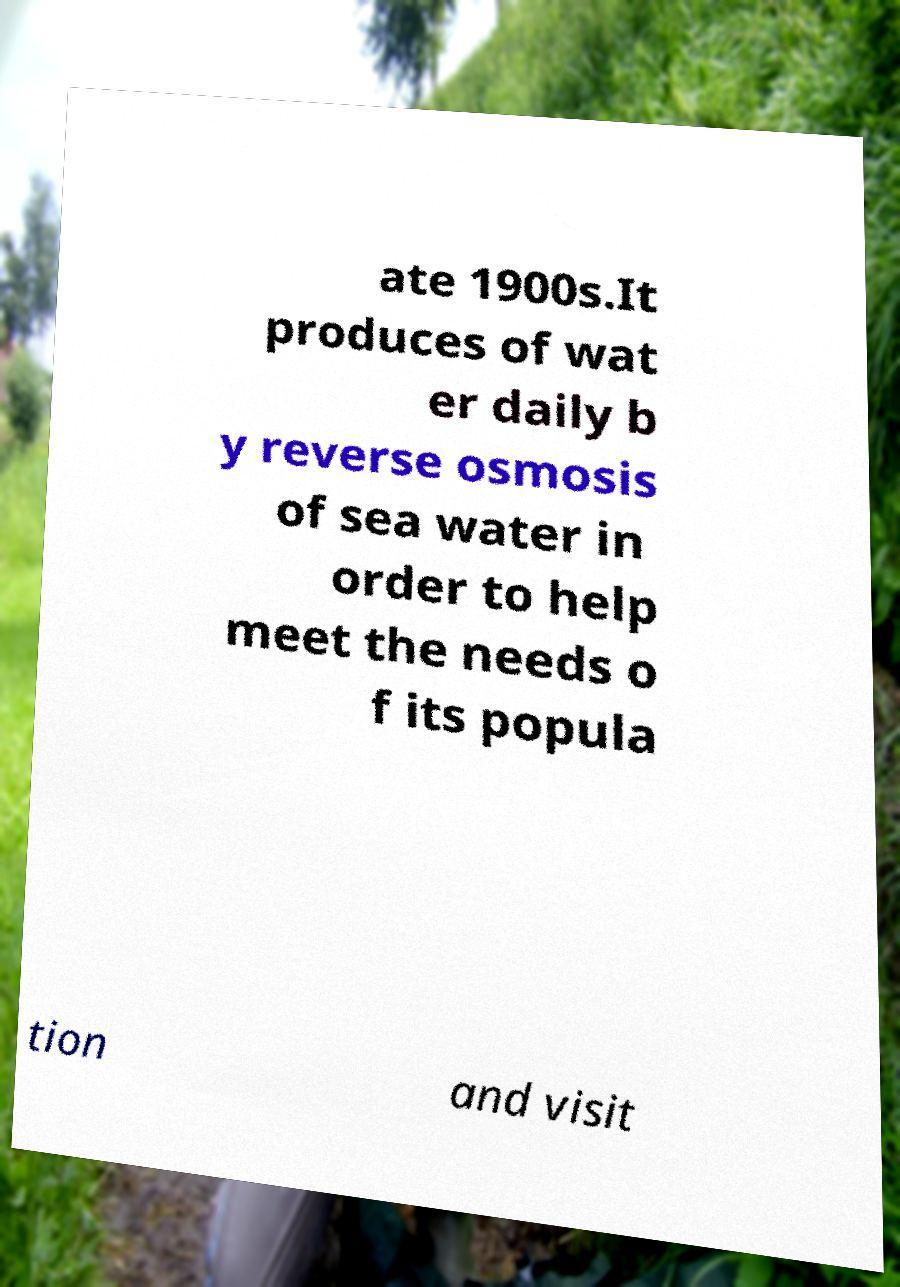Could you extract and type out the text from this image? ate 1900s.It produces of wat er daily b y reverse osmosis of sea water in order to help meet the needs o f its popula tion and visit 